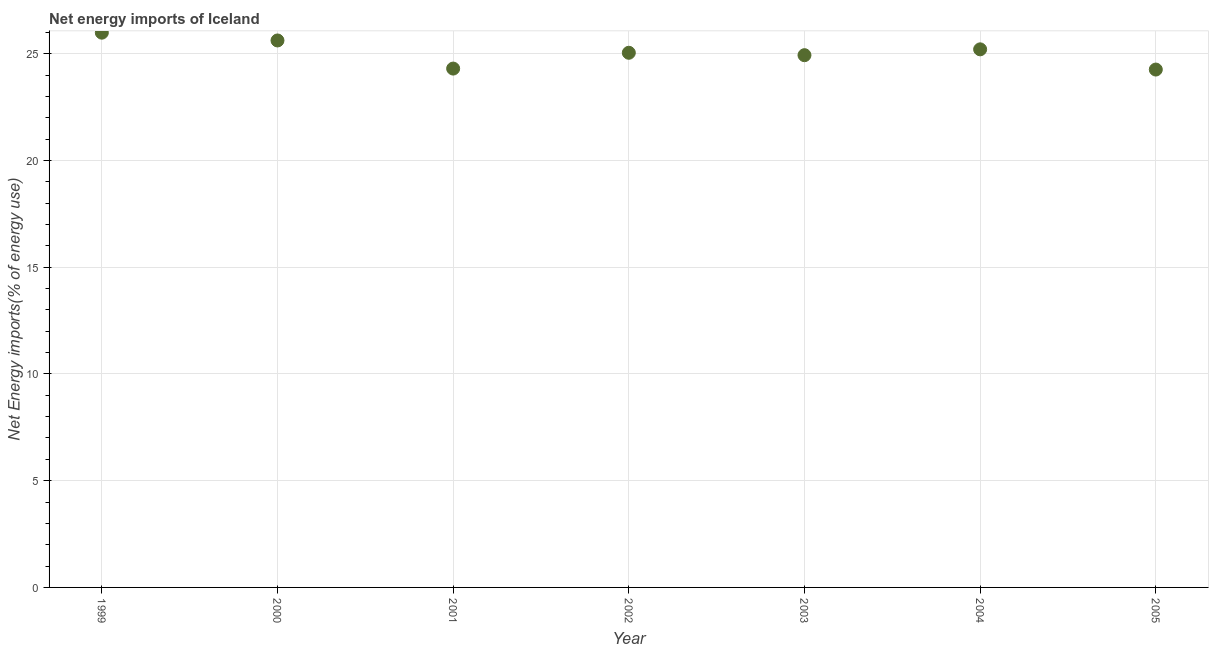What is the energy imports in 2004?
Your answer should be compact. 25.21. Across all years, what is the maximum energy imports?
Give a very brief answer. 25.99. Across all years, what is the minimum energy imports?
Provide a succinct answer. 24.26. In which year was the energy imports minimum?
Provide a short and direct response. 2005. What is the sum of the energy imports?
Your answer should be very brief. 175.36. What is the difference between the energy imports in 2003 and 2005?
Ensure brevity in your answer.  0.67. What is the average energy imports per year?
Provide a short and direct response. 25.05. What is the median energy imports?
Provide a succinct answer. 25.05. In how many years, is the energy imports greater than 2 %?
Provide a short and direct response. 7. What is the ratio of the energy imports in 2001 to that in 2004?
Your response must be concise. 0.96. Is the difference between the energy imports in 2000 and 2001 greater than the difference between any two years?
Your response must be concise. No. What is the difference between the highest and the second highest energy imports?
Ensure brevity in your answer.  0.37. Is the sum of the energy imports in 2003 and 2005 greater than the maximum energy imports across all years?
Ensure brevity in your answer.  Yes. What is the difference between the highest and the lowest energy imports?
Keep it short and to the point. 1.73. How many years are there in the graph?
Make the answer very short. 7. What is the difference between two consecutive major ticks on the Y-axis?
Ensure brevity in your answer.  5. Does the graph contain any zero values?
Ensure brevity in your answer.  No. What is the title of the graph?
Ensure brevity in your answer.  Net energy imports of Iceland. What is the label or title of the X-axis?
Make the answer very short. Year. What is the label or title of the Y-axis?
Provide a short and direct response. Net Energy imports(% of energy use). What is the Net Energy imports(% of energy use) in 1999?
Ensure brevity in your answer.  25.99. What is the Net Energy imports(% of energy use) in 2000?
Your response must be concise. 25.62. What is the Net Energy imports(% of energy use) in 2001?
Keep it short and to the point. 24.31. What is the Net Energy imports(% of energy use) in 2002?
Offer a terse response. 25.05. What is the Net Energy imports(% of energy use) in 2003?
Your response must be concise. 24.93. What is the Net Energy imports(% of energy use) in 2004?
Provide a short and direct response. 25.21. What is the Net Energy imports(% of energy use) in 2005?
Offer a very short reply. 24.26. What is the difference between the Net Energy imports(% of energy use) in 1999 and 2000?
Provide a succinct answer. 0.37. What is the difference between the Net Energy imports(% of energy use) in 1999 and 2001?
Provide a succinct answer. 1.68. What is the difference between the Net Energy imports(% of energy use) in 1999 and 2002?
Provide a short and direct response. 0.94. What is the difference between the Net Energy imports(% of energy use) in 1999 and 2003?
Provide a short and direct response. 1.05. What is the difference between the Net Energy imports(% of energy use) in 1999 and 2004?
Make the answer very short. 0.78. What is the difference between the Net Energy imports(% of energy use) in 1999 and 2005?
Keep it short and to the point. 1.73. What is the difference between the Net Energy imports(% of energy use) in 2000 and 2001?
Give a very brief answer. 1.32. What is the difference between the Net Energy imports(% of energy use) in 2000 and 2002?
Give a very brief answer. 0.58. What is the difference between the Net Energy imports(% of energy use) in 2000 and 2003?
Keep it short and to the point. 0.69. What is the difference between the Net Energy imports(% of energy use) in 2000 and 2004?
Make the answer very short. 0.42. What is the difference between the Net Energy imports(% of energy use) in 2000 and 2005?
Your answer should be very brief. 1.36. What is the difference between the Net Energy imports(% of energy use) in 2001 and 2002?
Ensure brevity in your answer.  -0.74. What is the difference between the Net Energy imports(% of energy use) in 2001 and 2003?
Make the answer very short. -0.63. What is the difference between the Net Energy imports(% of energy use) in 2001 and 2004?
Provide a succinct answer. -0.9. What is the difference between the Net Energy imports(% of energy use) in 2001 and 2005?
Offer a terse response. 0.05. What is the difference between the Net Energy imports(% of energy use) in 2002 and 2003?
Offer a very short reply. 0.11. What is the difference between the Net Energy imports(% of energy use) in 2002 and 2004?
Provide a short and direct response. -0.16. What is the difference between the Net Energy imports(% of energy use) in 2002 and 2005?
Give a very brief answer. 0.79. What is the difference between the Net Energy imports(% of energy use) in 2003 and 2004?
Your response must be concise. -0.27. What is the difference between the Net Energy imports(% of energy use) in 2003 and 2005?
Provide a succinct answer. 0.67. What is the difference between the Net Energy imports(% of energy use) in 2004 and 2005?
Your answer should be very brief. 0.95. What is the ratio of the Net Energy imports(% of energy use) in 1999 to that in 2000?
Keep it short and to the point. 1.01. What is the ratio of the Net Energy imports(% of energy use) in 1999 to that in 2001?
Your response must be concise. 1.07. What is the ratio of the Net Energy imports(% of energy use) in 1999 to that in 2002?
Keep it short and to the point. 1.04. What is the ratio of the Net Energy imports(% of energy use) in 1999 to that in 2003?
Provide a short and direct response. 1.04. What is the ratio of the Net Energy imports(% of energy use) in 1999 to that in 2004?
Your response must be concise. 1.03. What is the ratio of the Net Energy imports(% of energy use) in 1999 to that in 2005?
Your answer should be compact. 1.07. What is the ratio of the Net Energy imports(% of energy use) in 2000 to that in 2001?
Offer a terse response. 1.05. What is the ratio of the Net Energy imports(% of energy use) in 2000 to that in 2002?
Give a very brief answer. 1.02. What is the ratio of the Net Energy imports(% of energy use) in 2000 to that in 2003?
Your response must be concise. 1.03. What is the ratio of the Net Energy imports(% of energy use) in 2000 to that in 2005?
Offer a terse response. 1.06. What is the ratio of the Net Energy imports(% of energy use) in 2001 to that in 2002?
Offer a terse response. 0.97. What is the ratio of the Net Energy imports(% of energy use) in 2001 to that in 2005?
Provide a succinct answer. 1. What is the ratio of the Net Energy imports(% of energy use) in 2002 to that in 2005?
Provide a short and direct response. 1.03. What is the ratio of the Net Energy imports(% of energy use) in 2003 to that in 2005?
Your response must be concise. 1.03. What is the ratio of the Net Energy imports(% of energy use) in 2004 to that in 2005?
Provide a succinct answer. 1.04. 